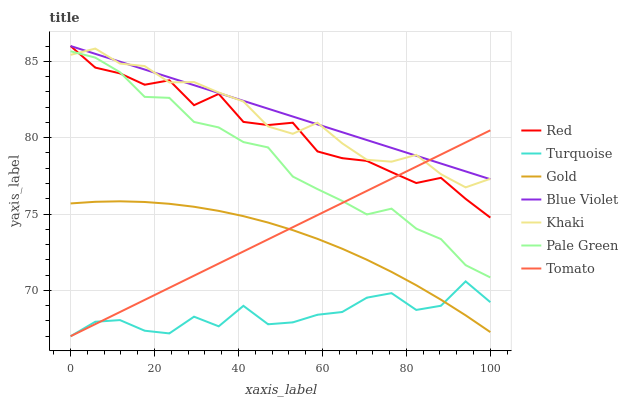Does Turquoise have the minimum area under the curve?
Answer yes or no. Yes. Does Blue Violet have the maximum area under the curve?
Answer yes or no. Yes. Does Khaki have the minimum area under the curve?
Answer yes or no. No. Does Khaki have the maximum area under the curve?
Answer yes or no. No. Is Blue Violet the smoothest?
Answer yes or no. Yes. Is Turquoise the roughest?
Answer yes or no. Yes. Is Khaki the smoothest?
Answer yes or no. No. Is Khaki the roughest?
Answer yes or no. No. Does Khaki have the lowest value?
Answer yes or no. No. Does Blue Violet have the highest value?
Answer yes or no. Yes. Does Khaki have the highest value?
Answer yes or no. No. Is Gold less than Blue Violet?
Answer yes or no. Yes. Is Khaki greater than Turquoise?
Answer yes or no. Yes. Does Khaki intersect Pale Green?
Answer yes or no. Yes. Is Khaki less than Pale Green?
Answer yes or no. No. Is Khaki greater than Pale Green?
Answer yes or no. No. Does Gold intersect Blue Violet?
Answer yes or no. No. 